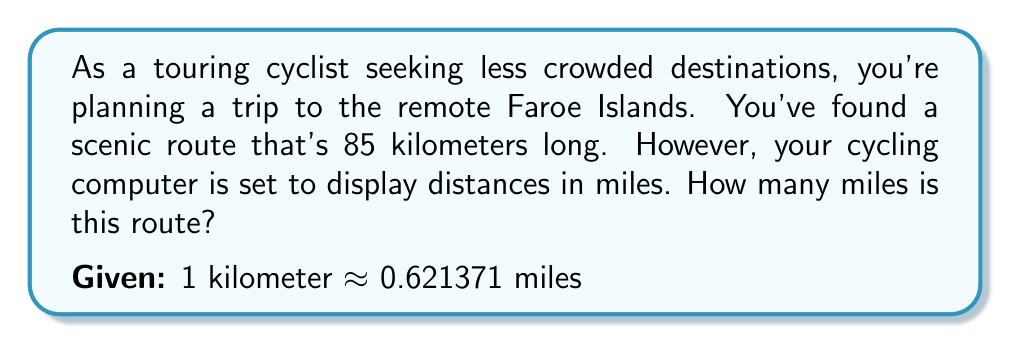Help me with this question. To convert kilometers to miles, we need to multiply the given distance by the conversion factor:

$$ 85 \text{ km} \times \frac{0.621371 \text{ miles}}{1 \text{ km}} $$

Let's break this down step-by-step:

1) Set up the conversion:
   $$ 85 \times 0.621371 $$

2) Multiply:
   $$ 85 \times 0.621371 = 52.81653500000001 $$

3) Round to a reasonable number of decimal places for practical use (two in this case):
   $$ 52.82 \text{ miles} $$

This conversion allows you to understand the route distance in miles, which your cycling computer uses.
Answer: $52.82$ miles 